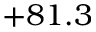<formula> <loc_0><loc_0><loc_500><loc_500>+ 8 1 . 3</formula> 